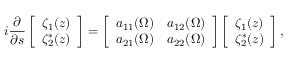Convert formula to latex. <formula><loc_0><loc_0><loc_500><loc_500>i \frac { \partial } { \partial s } \left [ \begin{array} { c } { \zeta _ { 1 } ( z ) } \\ { \zeta _ { 2 } ^ { \ast } ( z ) } \end{array} \right ] = \left [ \begin{array} { c c } { a _ { 1 1 } ( \Omega ) } & { a _ { 1 2 } ( \Omega ) } \\ { a _ { 2 1 } ( \Omega ) } & { a _ { 2 2 } ( \Omega ) } \end{array} \right ] \left [ \begin{array} { c } { \zeta _ { 1 } ( z ) } \\ { \zeta _ { 2 } ^ { \ast } ( z ) } \end{array} \right ] ,</formula> 